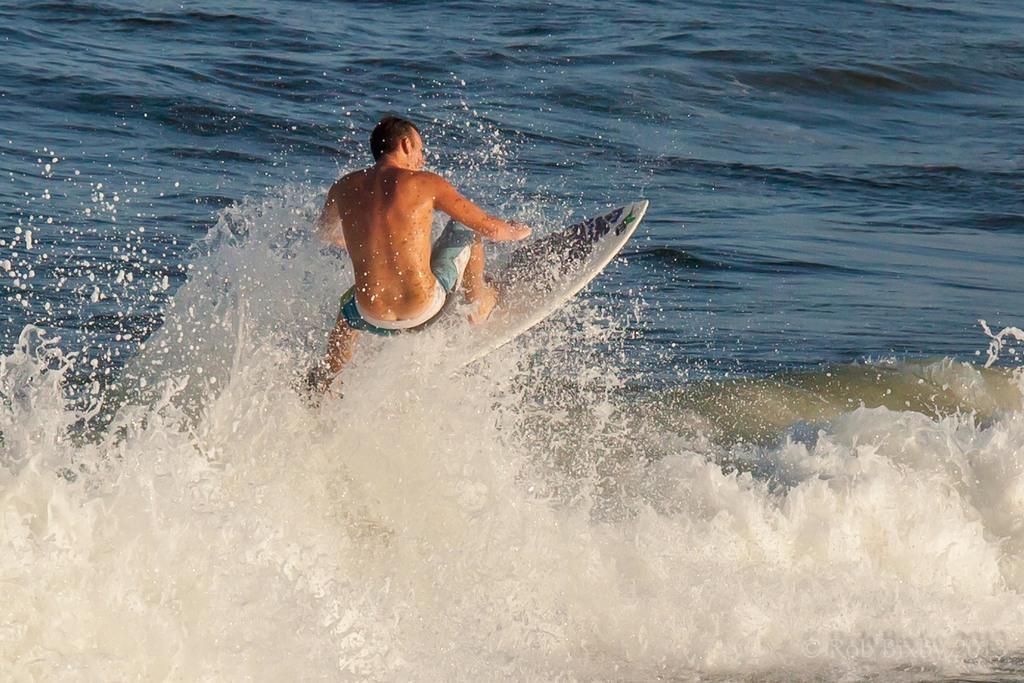Can you describe this image briefly? In the middle I can see a person is skiing in the ocean. This image is taken during a day in the ocean. 